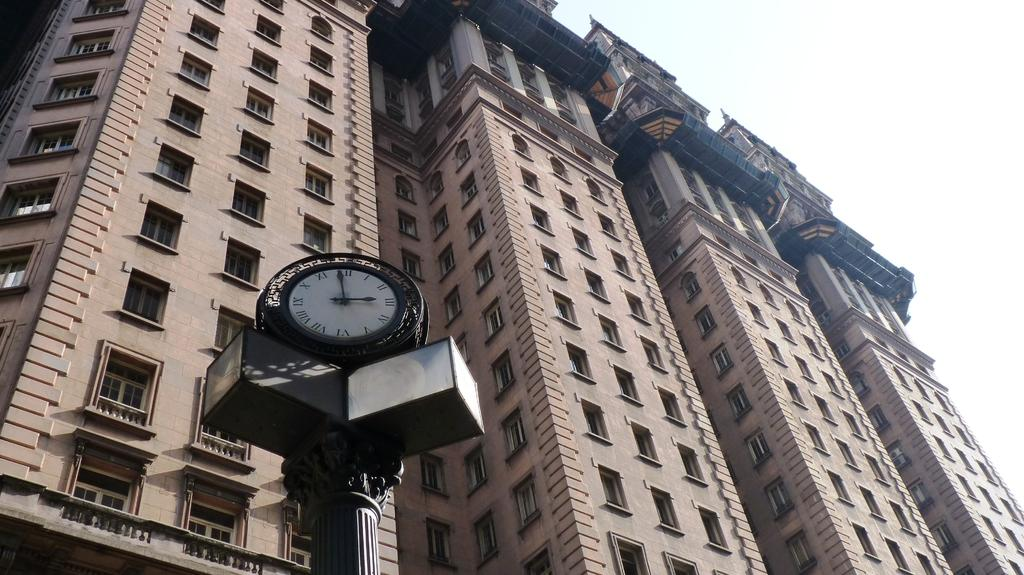<image>
Create a compact narrative representing the image presented. A clock has the numeral XII at the top and VI at the bottom. 